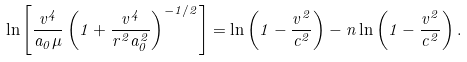<formula> <loc_0><loc_0><loc_500><loc_500>\ln \left [ \frac { v ^ { 4 } } { a _ { 0 } \mu } \left ( 1 + \frac { v ^ { 4 } } { r ^ { 2 } a _ { 0 } ^ { 2 } } \right ) ^ { - 1 / 2 } \right ] = \ln \left ( 1 - \frac { v ^ { 2 } } { c ^ { 2 } } \right ) - n \ln \left ( 1 - \frac { v ^ { 2 } } { c ^ { 2 } } \right ) .</formula> 